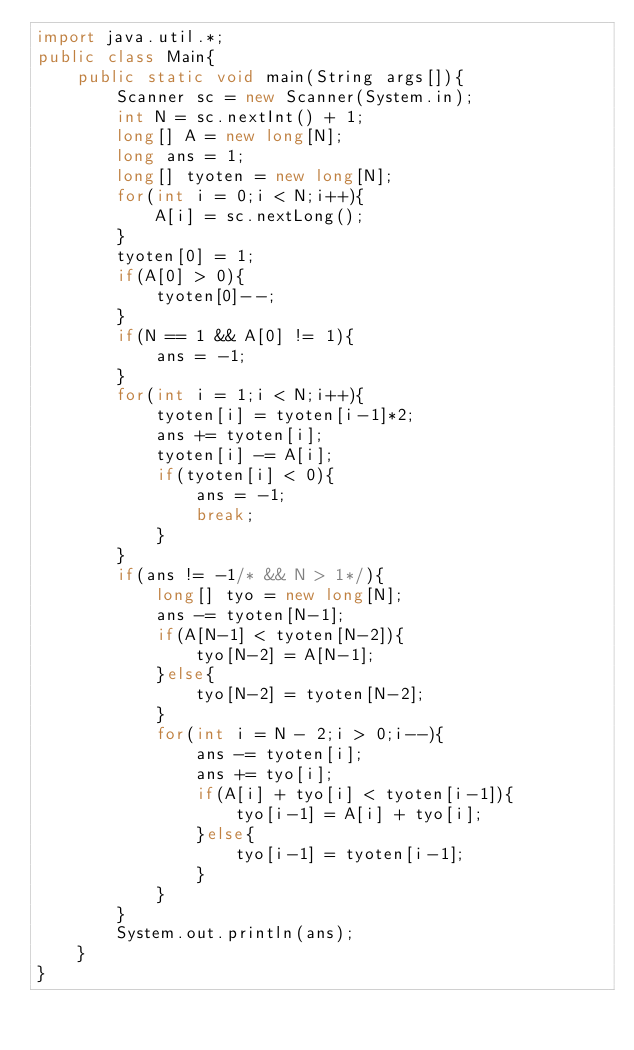Convert code to text. <code><loc_0><loc_0><loc_500><loc_500><_Java_>import java.util.*;
public class Main{
	public static void main(String args[]){
		Scanner sc = new Scanner(System.in);
		int N = sc.nextInt() + 1;
		long[] A = new long[N];
		long ans = 1;
		long[] tyoten = new long[N];
		for(int i = 0;i < N;i++){
			A[i] = sc.nextLong();
		}
		tyoten[0] = 1;
		if(A[0] > 0){
			tyoten[0]--;
		}
		if(N == 1 && A[0] != 1){
			ans = -1;
		}
		for(int i = 1;i < N;i++){
			tyoten[i] = tyoten[i-1]*2;
			ans += tyoten[i];
			tyoten[i] -= A[i];
			if(tyoten[i] < 0){
				ans = -1;
				break;
			}
		}
		if(ans != -1/* && N > 1*/){
			long[] tyo = new long[N];
			ans -= tyoten[N-1];
			if(A[N-1] < tyoten[N-2]){
				tyo[N-2] = A[N-1];
			}else{
				tyo[N-2] = tyoten[N-2];
			}
			for(int i = N - 2;i > 0;i--){
				ans -= tyoten[i];
				ans += tyo[i];
				if(A[i] + tyo[i] < tyoten[i-1]){
					tyo[i-1] = A[i] + tyo[i];
				}else{
					tyo[i-1] = tyoten[i-1];
				}
			}
		}
		System.out.println(ans);
	}
}
</code> 